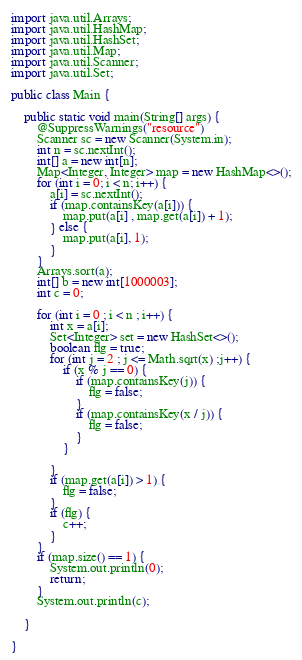<code> <loc_0><loc_0><loc_500><loc_500><_Java_>import java.util.Arrays;
import java.util.HashMap;
import java.util.HashSet;
import java.util.Map;
import java.util.Scanner;
import java.util.Set;

public class Main {

    public static void main(String[] args) {
        @SuppressWarnings("resource")
        Scanner sc = new Scanner(System.in);
        int n = sc.nextInt();
        int[] a = new int[n];
        Map<Integer, Integer> map = new HashMap<>();
        for (int i = 0; i < n; i++) {
            a[i] = sc.nextInt();
            if (map.containsKey(a[i])) {
                map.put(a[i] , map.get(a[i]) + 1);
            } else {
                map.put(a[i], 1);
            }
        }
        Arrays.sort(a);
        int[] b = new int[1000003];
        int c = 0;

        for (int i = 0 ; i < n ; i++) {
            int x = a[i];
            Set<Integer> set = new HashSet<>();
            boolean flg = true;
            for (int j = 2 ; j <= Math.sqrt(x) ;j++) {
                if (x % j == 0) {
                    if (map.containsKey(j)) {
                        flg = false;
                    }
                    if (map.containsKey(x / j)) {
                        flg = false;
                    }
                }

            }
            if (map.get(a[i]) > 1) {
                flg = false;
            }
            if (flg) {
                c++;
            }
        }
        if (map.size() == 1) {
            System.out.println(0);
            return;
        }
        System.out.println(c);

    }

}</code> 